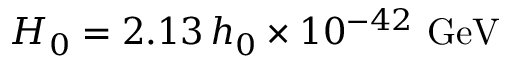Convert formula to latex. <formula><loc_0><loc_0><loc_500><loc_500>H _ { 0 } = 2 . 1 3 \, h _ { 0 } \times 1 0 ^ { - 4 2 } \, G e V</formula> 